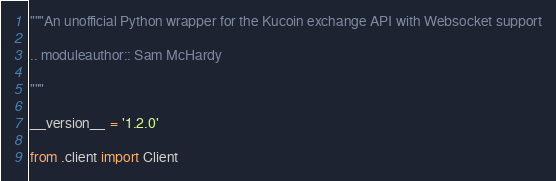<code> <loc_0><loc_0><loc_500><loc_500><_Python_>"""An unofficial Python wrapper for the Kucoin exchange API with Websocket support

.. moduleauthor:: Sam McHardy

"""

__version__ = '1.2.0'

from .client import Client</code> 